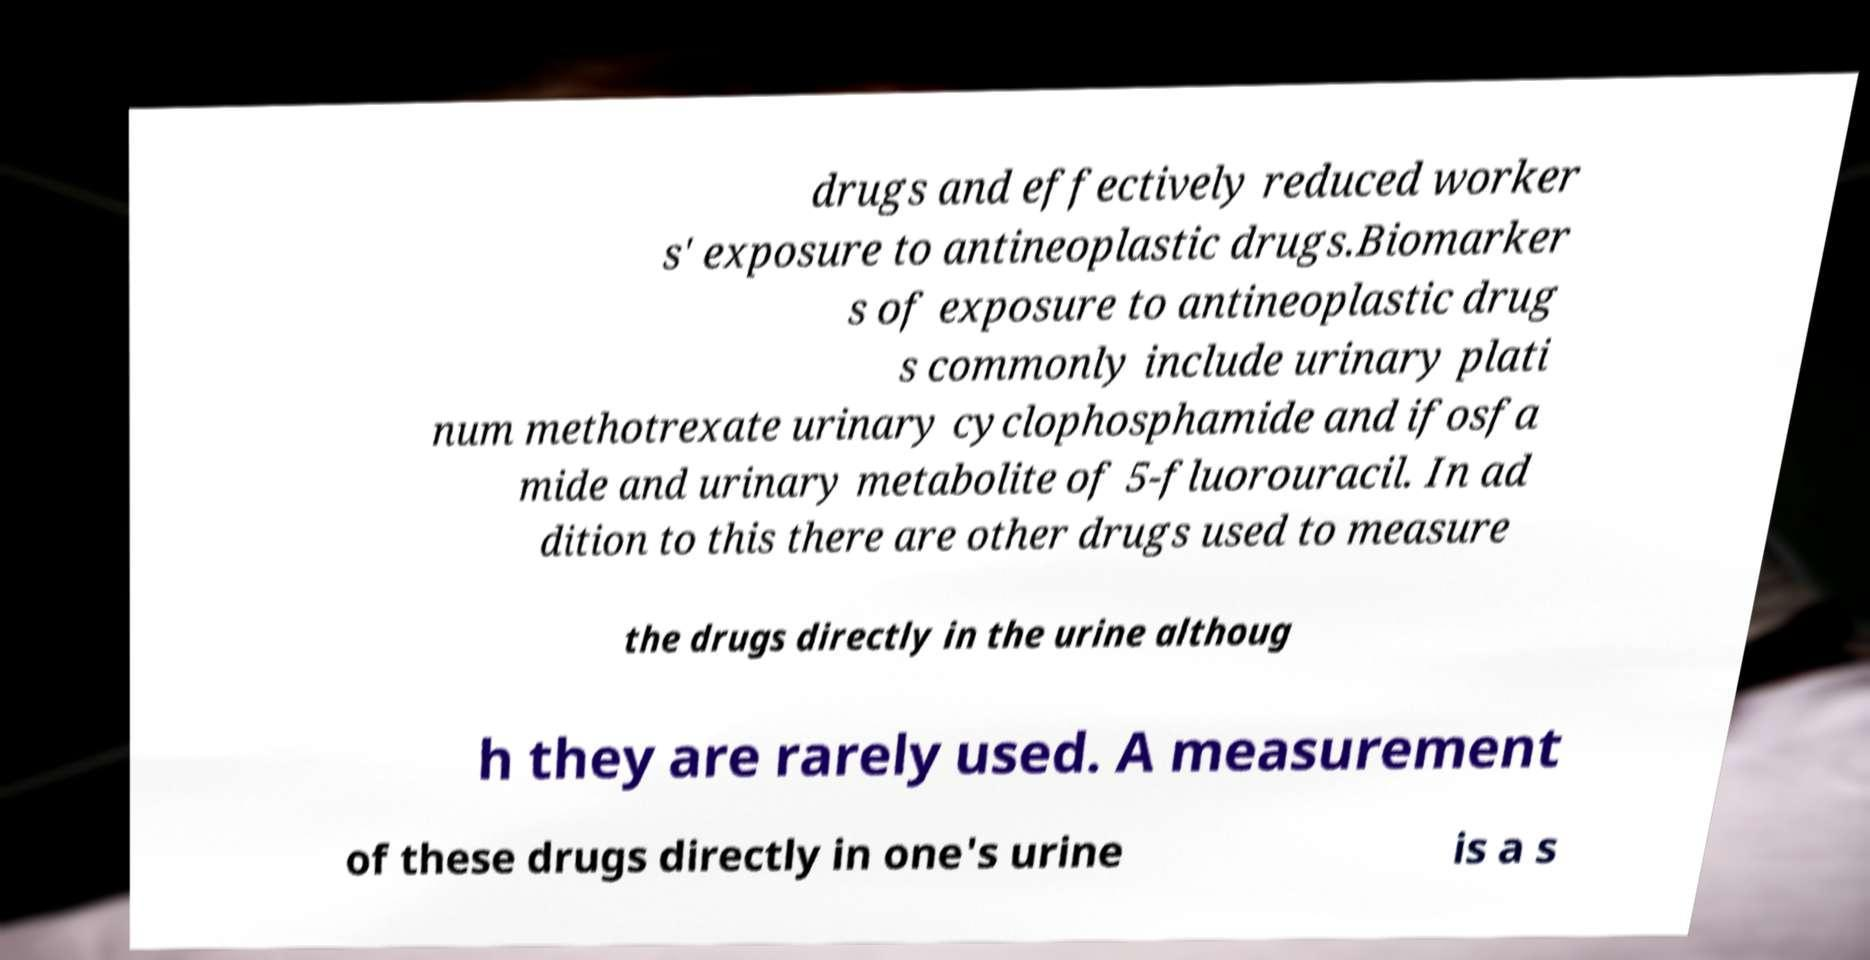Could you extract and type out the text from this image? drugs and effectively reduced worker s' exposure to antineoplastic drugs.Biomarker s of exposure to antineoplastic drug s commonly include urinary plati num methotrexate urinary cyclophosphamide and ifosfa mide and urinary metabolite of 5-fluorouracil. In ad dition to this there are other drugs used to measure the drugs directly in the urine althoug h they are rarely used. A measurement of these drugs directly in one's urine is a s 